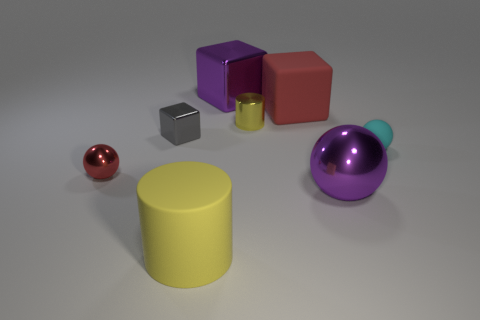Subtract all big purple balls. How many balls are left? 2 Subtract all red cubes. How many cubes are left? 2 Subtract all balls. How many objects are left? 5 Add 2 rubber cubes. How many objects exist? 10 Subtract 2 spheres. How many spheres are left? 1 Subtract all big blue metallic balls. Subtract all large red blocks. How many objects are left? 7 Add 6 tiny gray things. How many tiny gray things are left? 7 Add 4 tiny metallic objects. How many tiny metallic objects exist? 7 Subtract 1 purple spheres. How many objects are left? 7 Subtract all brown blocks. Subtract all cyan cylinders. How many blocks are left? 3 